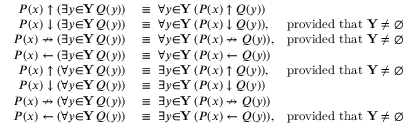<formula> <loc_0><loc_0><loc_500><loc_500>\begin{array} { r l r } { P ( x ) \uparrow ( \exists { y } { \in } Y \, Q ( y ) ) } & \equiv \ \forall { y } { \in } Y \, ( P ( x ) \uparrow Q ( y ) ) } \\ { P ( x ) \downarrow ( \exists { y } { \in } Y \, Q ( y ) ) } & \equiv \ \forall { y } { \in } Y \, ( P ( x ) \downarrow Q ( y ) ) , } & { { p r o v i d e d t h a t } Y \neq \emptyset } \\ { P ( x ) \nrightarrow ( \exists { y } { \in } Y \, Q ( y ) ) } & \equiv \ \forall { y } { \in } Y \, ( P ( x ) \nrightarrow Q ( y ) ) , } & { { p r o v i d e d t h a t } Y \neq \emptyset } \\ { P ( x ) \gets ( \exists { y } { \in } Y \, Q ( y ) ) } & \equiv \ \forall { y } { \in } Y \, ( P ( x ) \gets Q ( y ) ) } \\ { P ( x ) \uparrow ( \forall { y } { \in } Y \, Q ( y ) ) } & \equiv \ \exists { y } { \in } Y \, ( P ( x ) \uparrow Q ( y ) ) , } & { { p r o v i d e d t h a t } Y \neq \emptyset } \\ { P ( x ) \downarrow ( \forall { y } { \in } Y \, Q ( y ) ) } & \equiv \ \exists { y } { \in } Y \, ( P ( x ) \downarrow Q ( y ) ) } \\ { P ( x ) \nrightarrow ( \forall { y } { \in } Y \, Q ( y ) ) } & \equiv \ \exists { y } { \in } Y \, ( P ( x ) \nrightarrow Q ( y ) ) } \\ { P ( x ) \gets ( \forall { y } { \in } Y \, Q ( y ) ) } & \equiv \ \exists { y } { \in } Y \, ( P ( x ) \gets Q ( y ) ) , } & { { p r o v i d e d t h a t } Y \neq \emptyset } \end{array}</formula> 